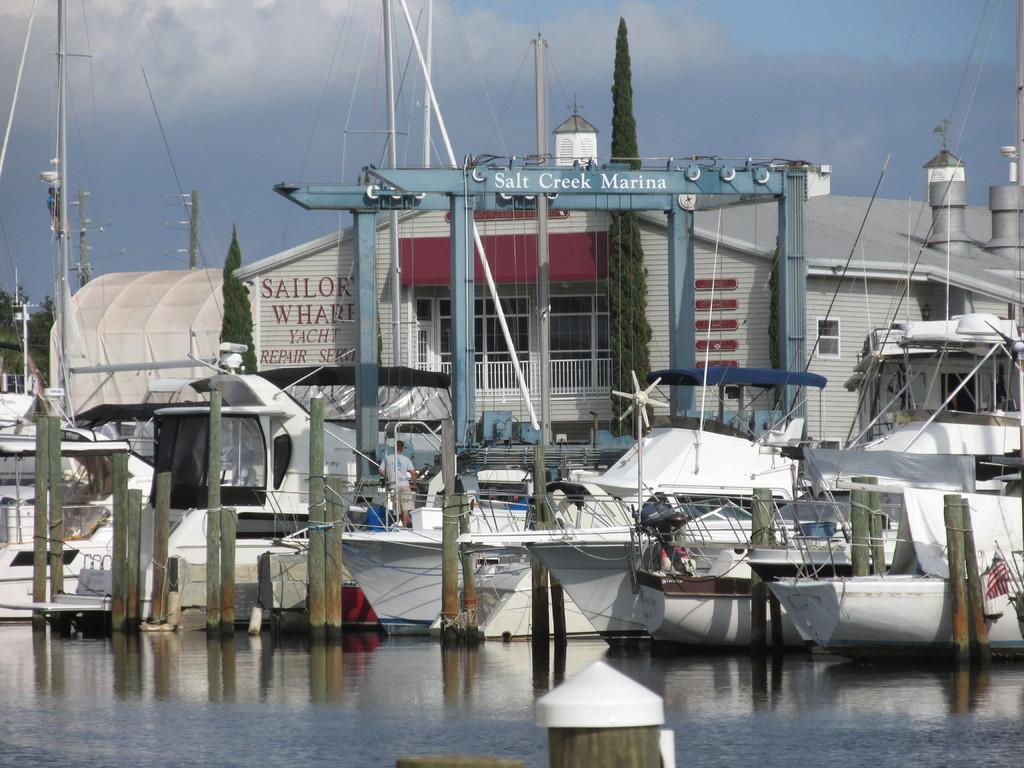<image>
Create a compact narrative representing the image presented. Boats docked by a building which says "Salt Creek Marina". 